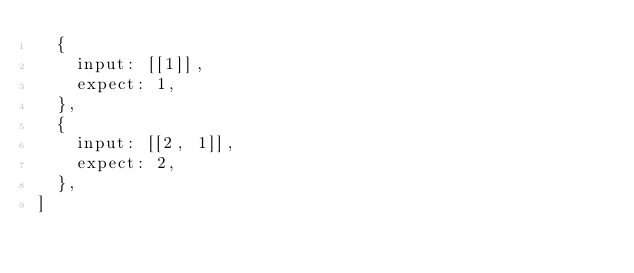Convert code to text. <code><loc_0><loc_0><loc_500><loc_500><_JavaScript_>  {
    input: [[1]],
    expect: 1,
  },
  {
    input: [[2, 1]],
    expect: 2,
  },
]
</code> 